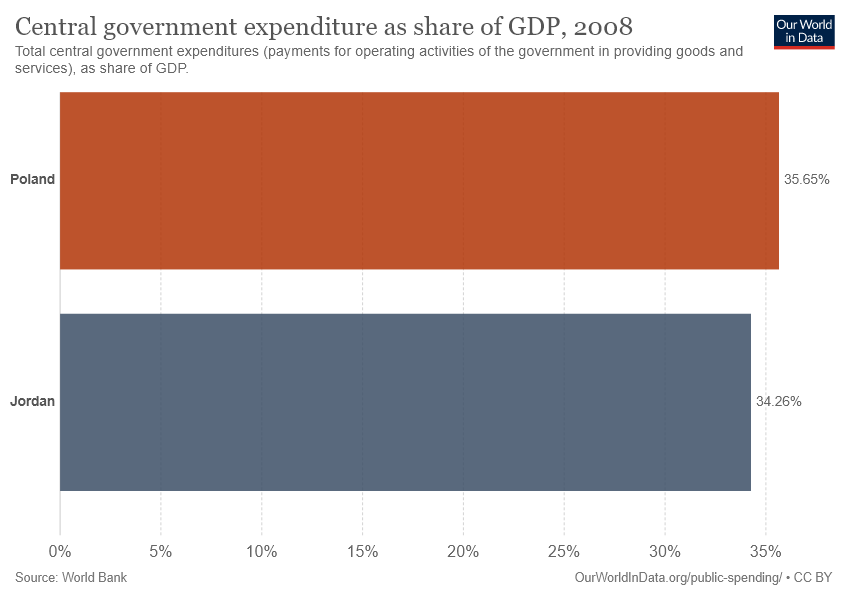What does the size of the government expenditure bars tell us about the individual economies? The size of the bars for government expenditures as a share of GDP suggests that both countries allocated a significant portion of their GDP to government activities. This can indicate a substantial level of government involvement in providing goods and services in their respective economies. 